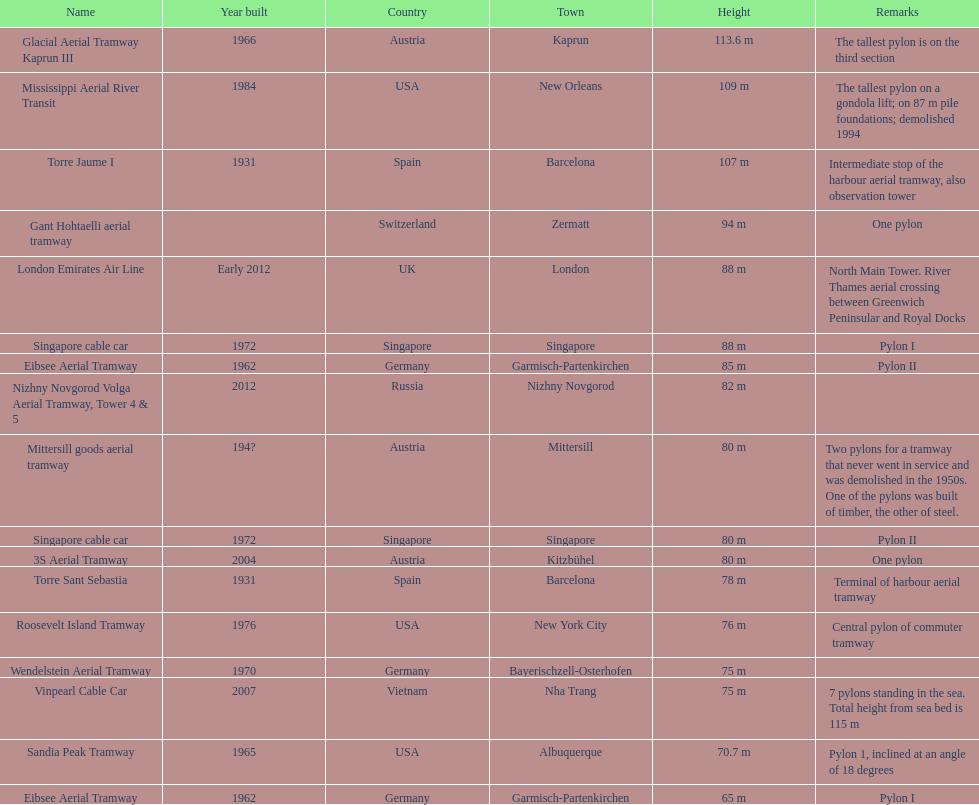Which pylon is the least high? Eibsee Aerial Tramway. 